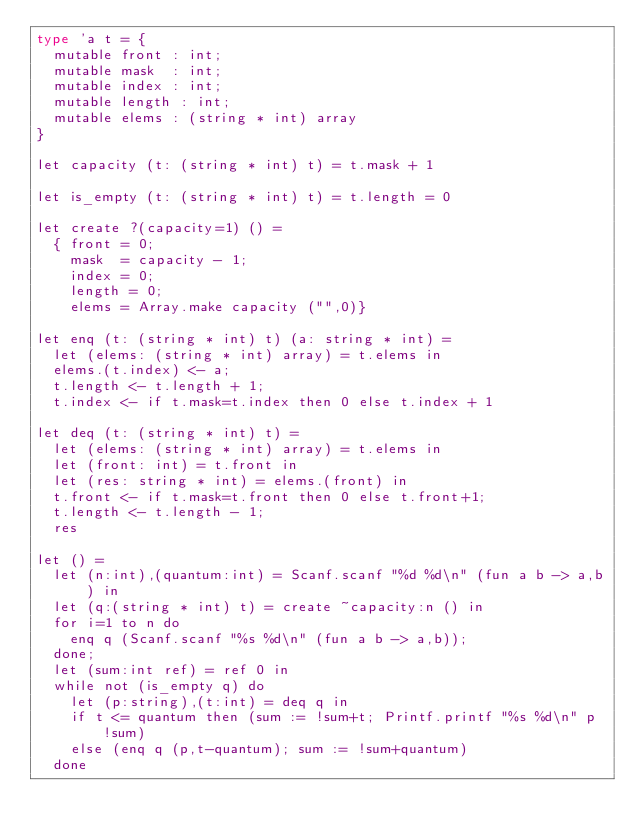Convert code to text. <code><loc_0><loc_0><loc_500><loc_500><_OCaml_>type 'a t = {
  mutable front : int;
  mutable mask  : int;
  mutable index : int;
  mutable length : int;
  mutable elems : (string * int) array
}

let capacity (t: (string * int) t) = t.mask + 1

let is_empty (t: (string * int) t) = t.length = 0

let create ?(capacity=1) () =
  { front = 0;
    mask  = capacity - 1;
    index = 0;
    length = 0;
    elems = Array.make capacity ("",0)}

let enq (t: (string * int) t) (a: string * int) =
  let (elems: (string * int) array) = t.elems in
  elems.(t.index) <- a;
  t.length <- t.length + 1;
  t.index <- if t.mask=t.index then 0 else t.index + 1

let deq (t: (string * int) t) =
  let (elems: (string * int) array) = t.elems in
  let (front: int) = t.front in
  let (res: string * int) = elems.(front) in
  t.front <- if t.mask=t.front then 0 else t.front+1;
  t.length <- t.length - 1;
  res

let () =
  let (n:int),(quantum:int) = Scanf.scanf "%d %d\n" (fun a b -> a,b) in
  let (q:(string * int) t) = create ~capacity:n () in
  for i=1 to n do
    enq q (Scanf.scanf "%s %d\n" (fun a b -> a,b));
  done;
  let (sum:int ref) = ref 0 in
  while not (is_empty q) do
    let (p:string),(t:int) = deq q in
    if t <= quantum then (sum := !sum+t; Printf.printf "%s %d\n" p !sum)
    else (enq q (p,t-quantum); sum := !sum+quantum)
  done</code> 